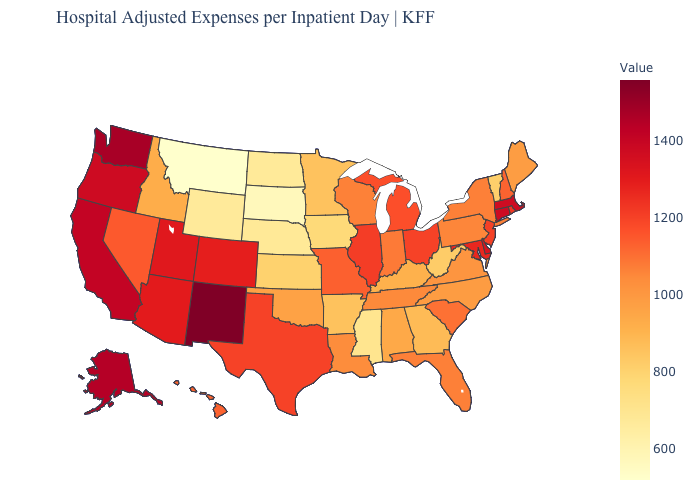Does Minnesota have the highest value in the USA?
Concise answer only. No. Which states have the lowest value in the USA?
Be succinct. Montana. Does the map have missing data?
Keep it brief. No. Does Nevada have the highest value in the USA?
Concise answer only. No. Which states have the highest value in the USA?
Concise answer only. New Mexico. Which states have the highest value in the USA?
Give a very brief answer. New Mexico. Among the states that border Illinois , which have the lowest value?
Give a very brief answer. Iowa. 